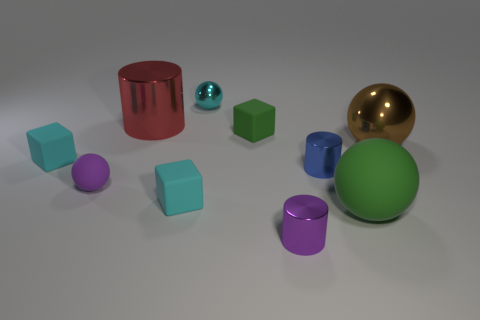Subtract all cylinders. How many objects are left? 7 Add 3 small blue metallic cylinders. How many small blue metallic cylinders are left? 4 Add 8 large brown things. How many large brown things exist? 9 Subtract 0 yellow balls. How many objects are left? 10 Subtract all purple matte things. Subtract all tiny blue things. How many objects are left? 8 